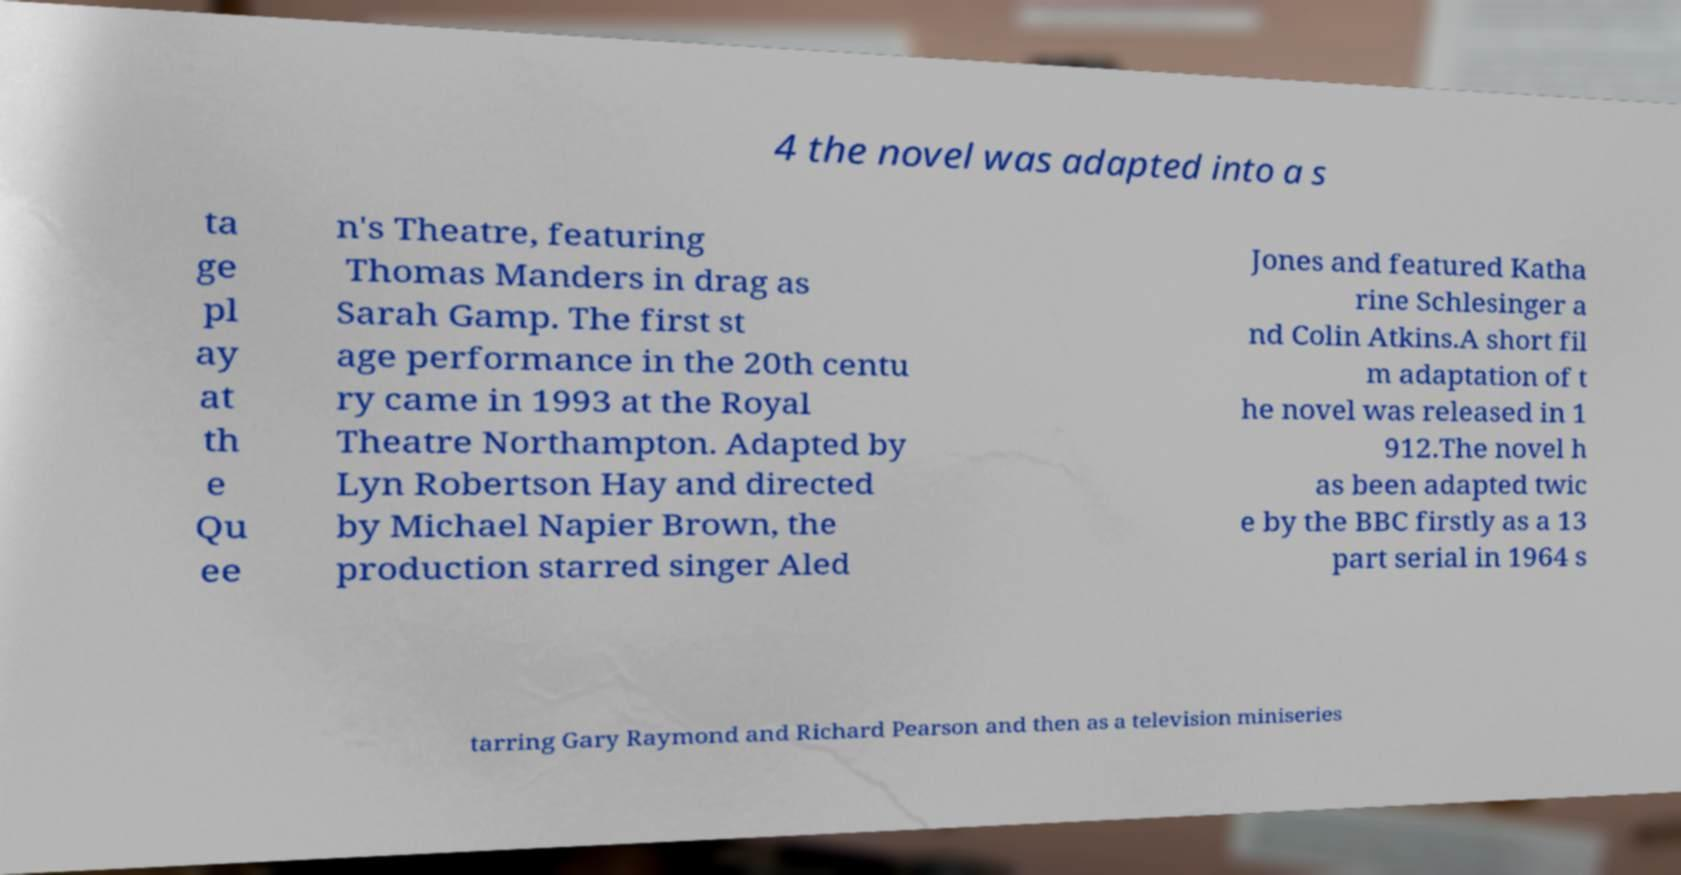I need the written content from this picture converted into text. Can you do that? 4 the novel was adapted into a s ta ge pl ay at th e Qu ee n's Theatre, featuring Thomas Manders in drag as Sarah Gamp. The first st age performance in the 20th centu ry came in 1993 at the Royal Theatre Northampton. Adapted by Lyn Robertson Hay and directed by Michael Napier Brown, the production starred singer Aled Jones and featured Katha rine Schlesinger a nd Colin Atkins.A short fil m adaptation of t he novel was released in 1 912.The novel h as been adapted twic e by the BBC firstly as a 13 part serial in 1964 s tarring Gary Raymond and Richard Pearson and then as a television miniseries 